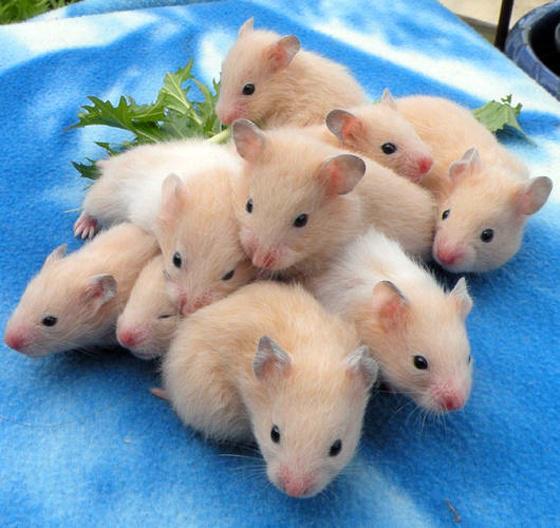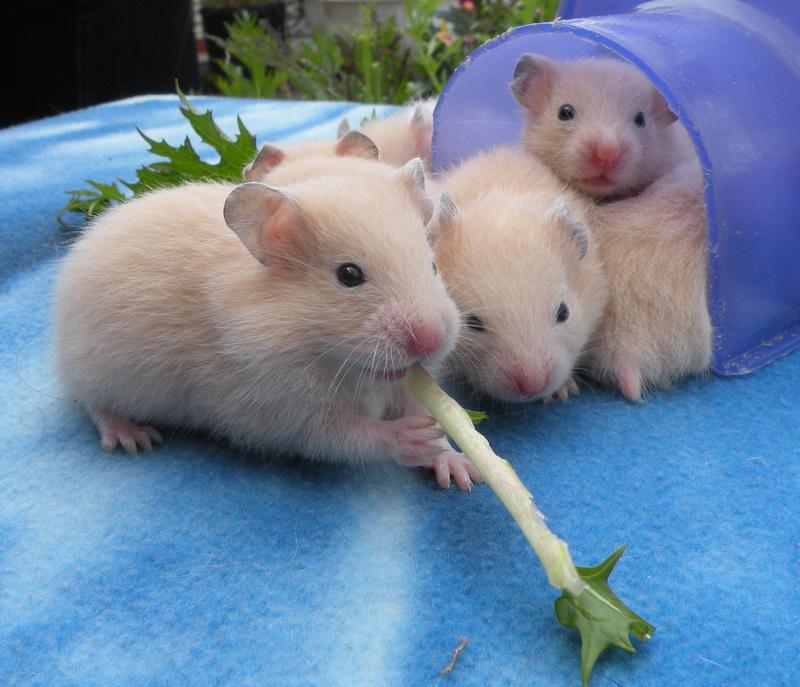The first image is the image on the left, the second image is the image on the right. Considering the images on both sides, is "The right image contains at least one rodent standing on a blue cloth." valid? Answer yes or no. Yes. 